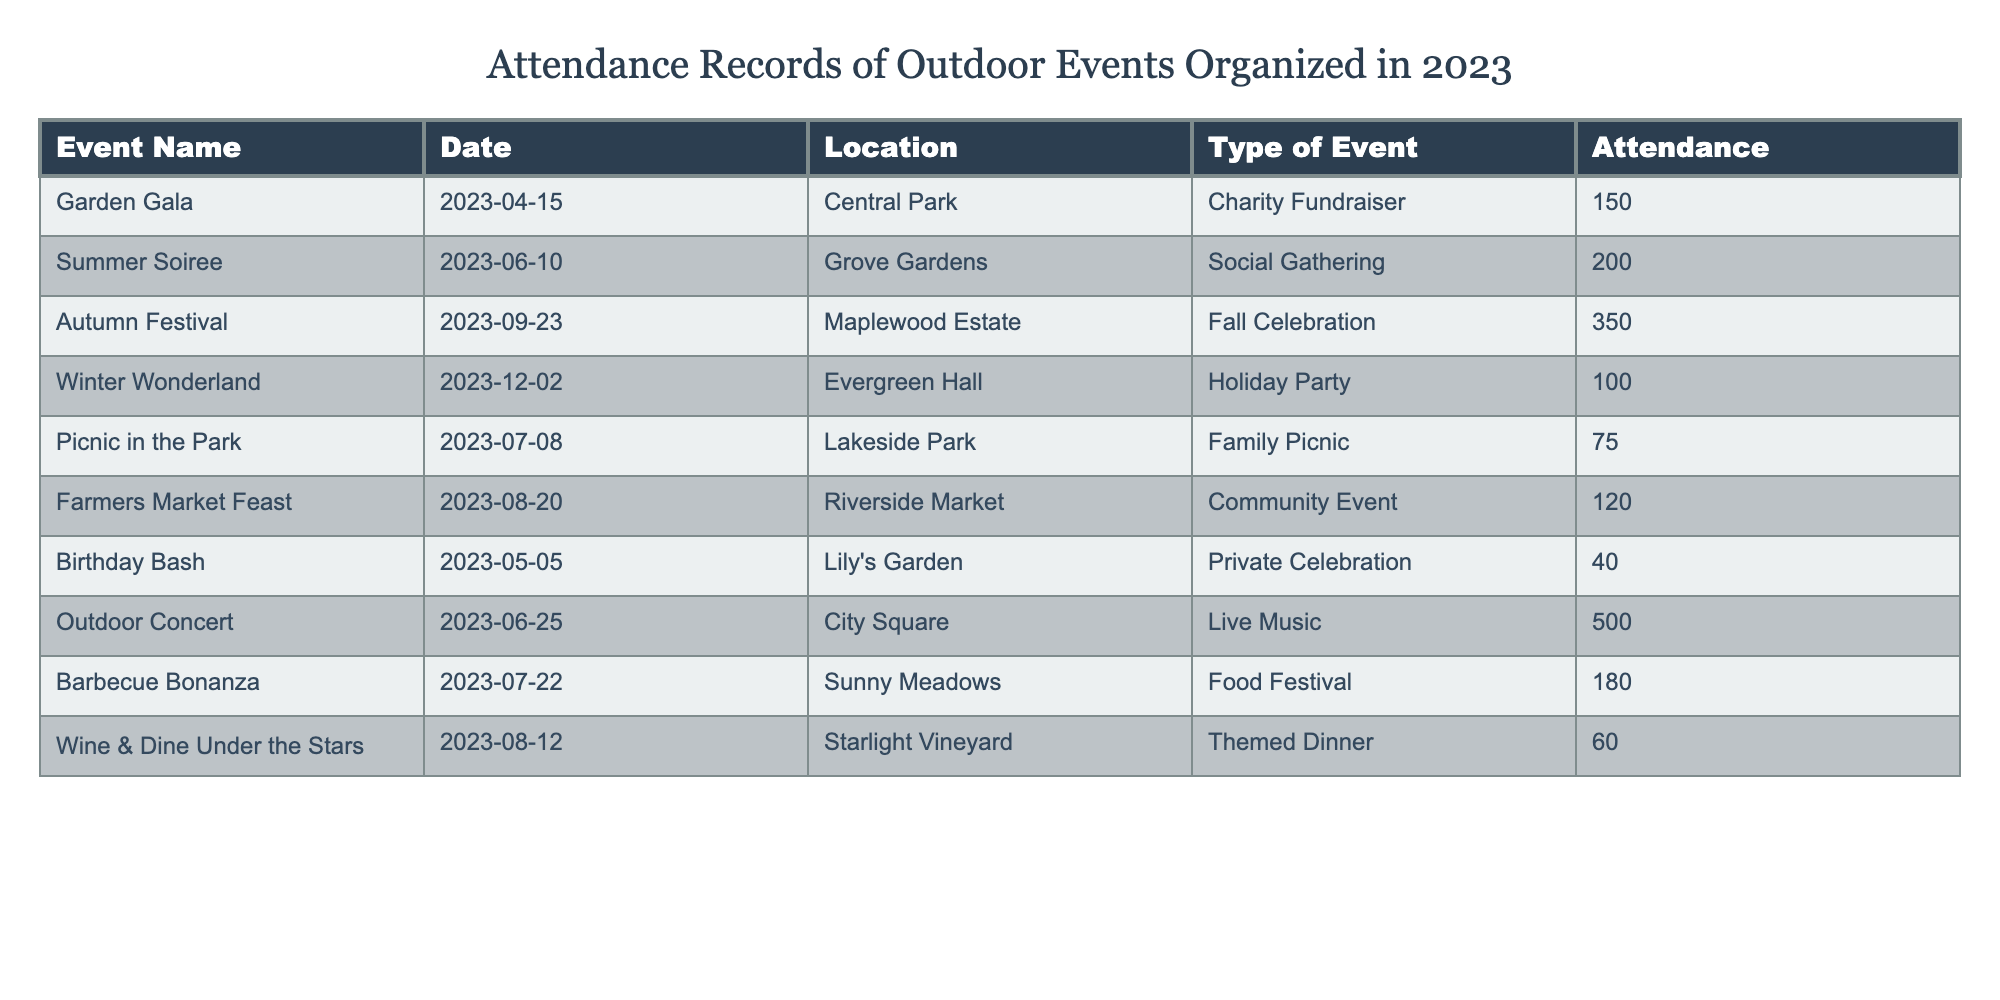What was the total attendance for the Summer Soiree? The table shows that the attendance for the Summer Soiree is listed as 200.
Answer: 200 Which event had the highest attendance? By looking at the attendance figures in the table, the Outdoor Concert has the highest attendance with 500 participants.
Answer: Outdoor Concert How many attendees were there at the Garden Gala and Birthday Bash combined? The Garden Gala had 150 attendees, and the Birthday Bash had 40. Adding these figures together gives 150 + 40 = 190.
Answer: 190 Is the Winter Wonderland event considered a larger gathering than the Picnic in the Park? The Winter Wonderland had 100 attendees, while the Picnic in the Park had 75. Since 100 is greater than 75, the Winter Wonderland is indeed a larger gathering.
Answer: Yes What is the average attendance of all the events listed? To find the average attendance, we first sum all the attendance figures, which are 150, 200, 350, 100, 75, 120, 40, 500, 180, and 60. The total is 1875, and there are 10 events, so the average is 1875 / 10 = 187.5.
Answer: 187.5 How many events had attendance figures below 100? The events with attendance figures below 100 are the Birthday Bash (40) and the Picnic in the Park (75). Therefore, there are two events that fall below 100 attendees.
Answer: 2 What was the difference in attendance between the Autumn Festival and the Winter Wonderland? The Autumn Festival had 350 attendees, and the Winter Wonderland had 100. The difference is calculated by subtracting these figures: 350 - 100 = 250.
Answer: 250 Did more people attend the Food Festival than the Holiday Party? The Barbecue Bonanza (Food Festival) had 180 attendees, while the Winter Wonderland (Holiday Party) had 100. Since 180 is greater than 100, more people attended the Food Festival.
Answer: Yes Which event had the least attendance? Looking at the table, the event with the least attendance is the Birthday Bash, which had 40 attendees.
Answer: Birthday Bash If we include the Winter Wonderland, how many total attendees from events in December were recorded? Only the Winter Wonderland is an event in December with 100 attendees. Thus, the total attendance for December events is simply 100.
Answer: 100 